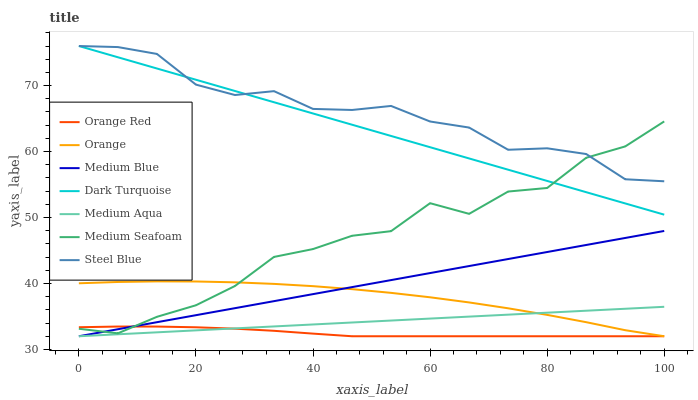Does Medium Blue have the minimum area under the curve?
Answer yes or no. No. Does Medium Blue have the maximum area under the curve?
Answer yes or no. No. Is Medium Blue the smoothest?
Answer yes or no. No. Is Medium Blue the roughest?
Answer yes or no. No. Does Steel Blue have the lowest value?
Answer yes or no. No. Does Medium Blue have the highest value?
Answer yes or no. No. Is Orange less than Dark Turquoise?
Answer yes or no. Yes. Is Dark Turquoise greater than Orange?
Answer yes or no. Yes. Does Orange intersect Dark Turquoise?
Answer yes or no. No. 